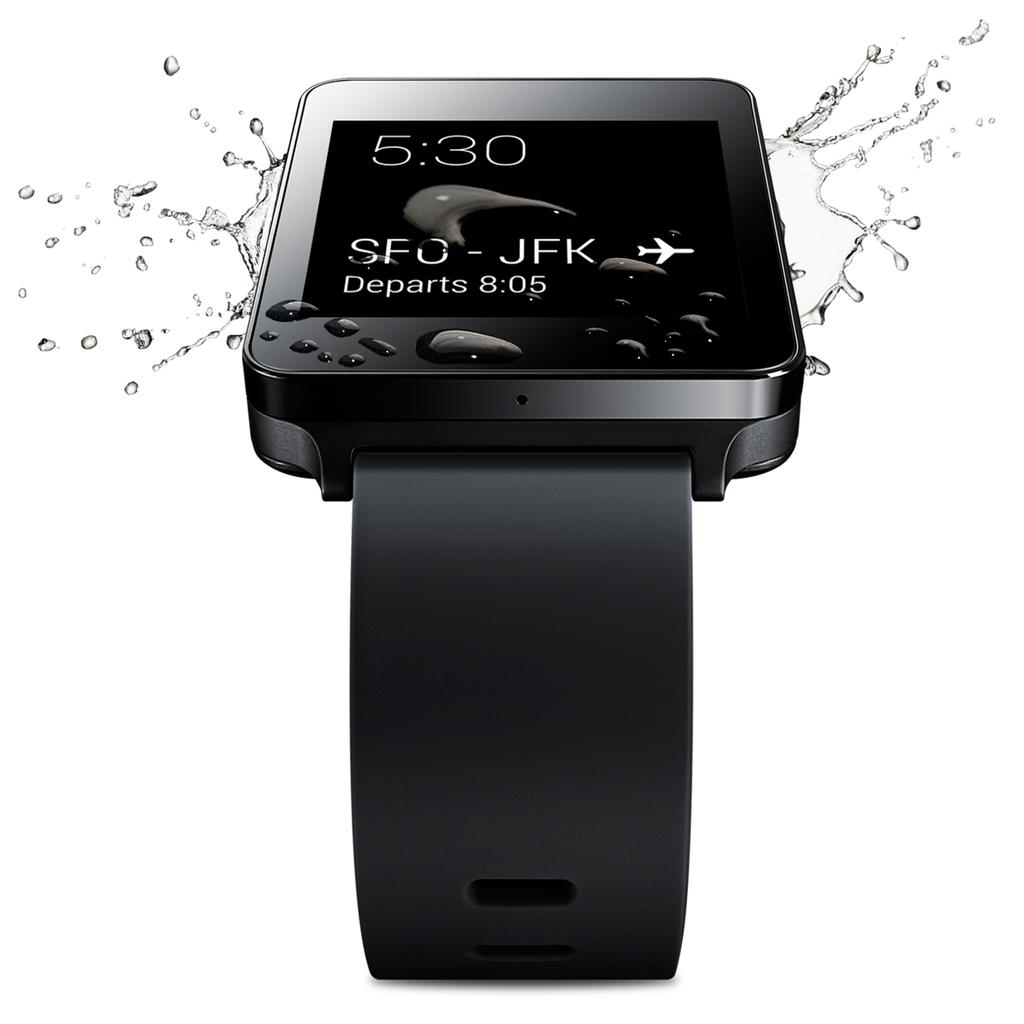<image>
Render a clear and concise summary of the photo. an sfc label that is on a watch 